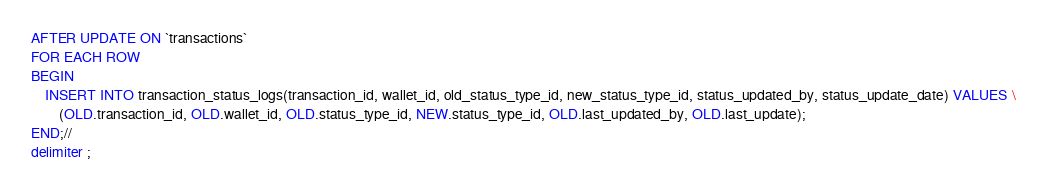<code> <loc_0><loc_0><loc_500><loc_500><_SQL_>AFTER UPDATE ON `transactions` 
FOR EACH ROW
BEGIN
    INSERT INTO transaction_status_logs(transaction_id, wallet_id, old_status_type_id, new_status_type_id, status_updated_by, status_update_date) VALUES \
        (OLD.transaction_id, OLD.wallet_id, OLD.status_type_id, NEW.status_type_id, OLD.last_updated_by, OLD.last_update);
END;//
delimiter ;
</code> 